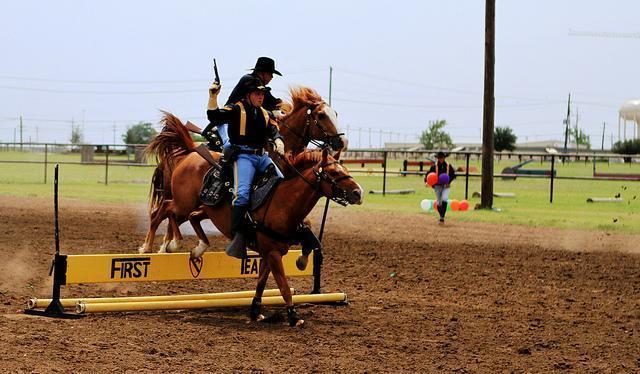How many horses are there?
Give a very brief answer. 2. 